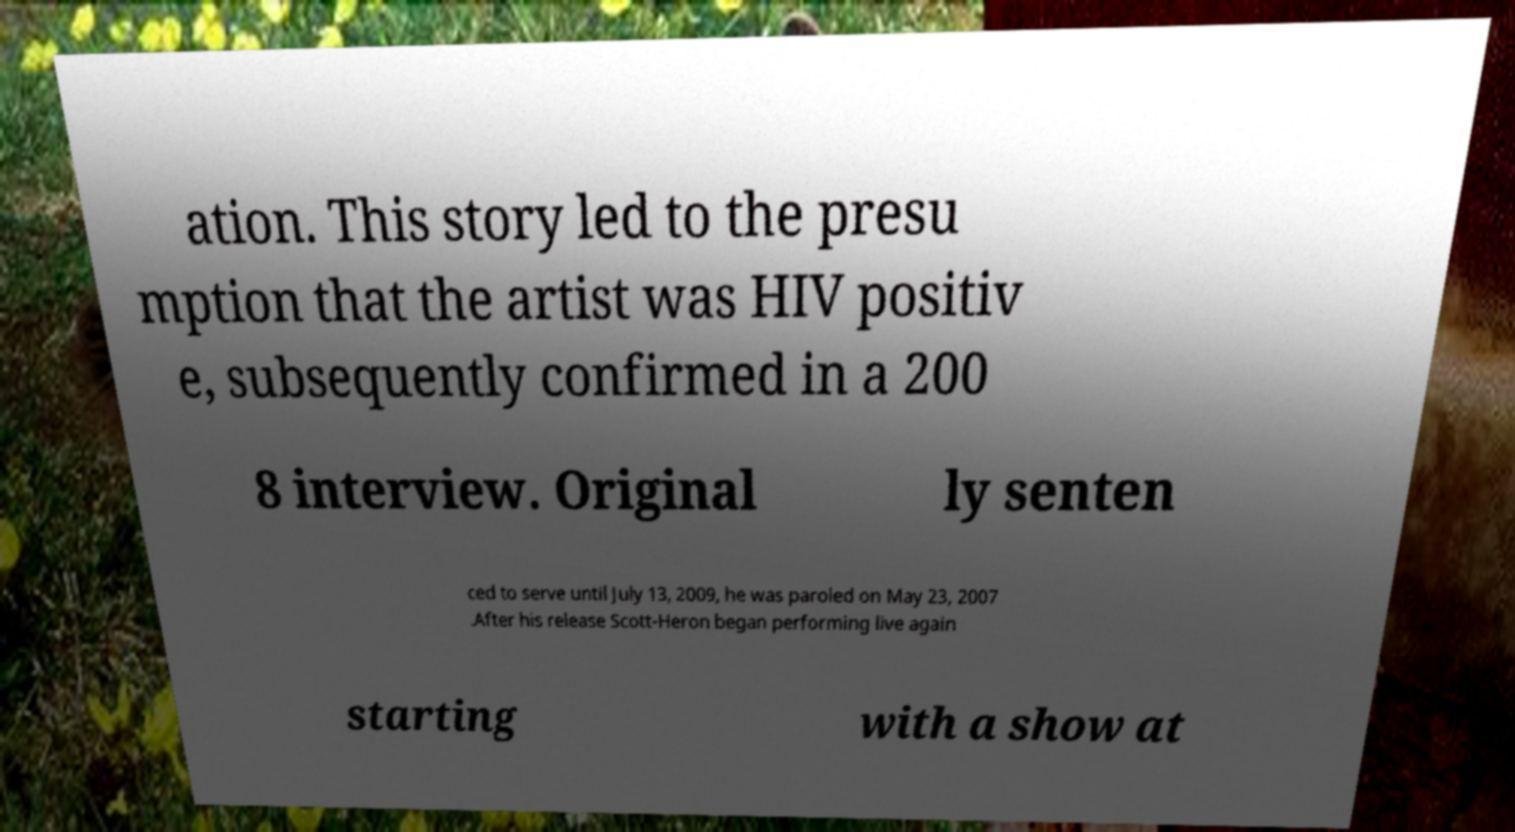There's text embedded in this image that I need extracted. Can you transcribe it verbatim? ation. This story led to the presu mption that the artist was HIV positiv e, subsequently confirmed in a 200 8 interview. Original ly senten ced to serve until July 13, 2009, he was paroled on May 23, 2007 .After his release Scott-Heron began performing live again starting with a show at 